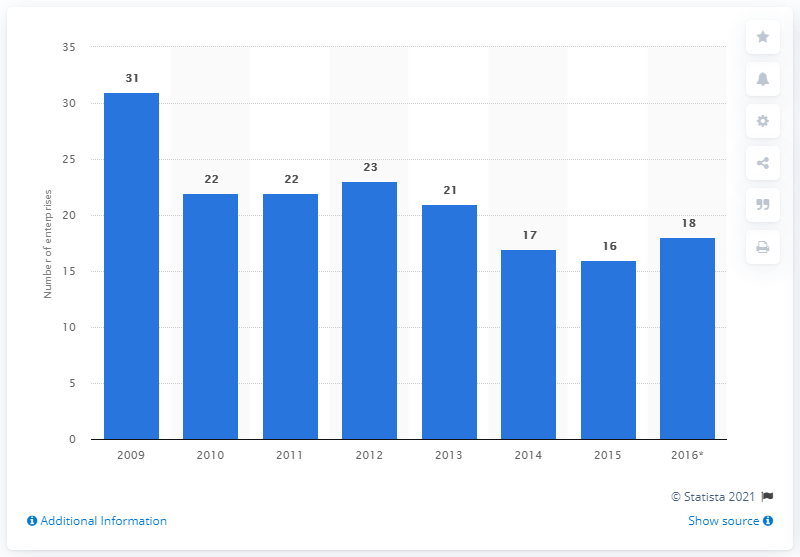List a handful of essential elements in this visual. In 2015, there were 16 enterprises in the Czech Republic that were engaged in the manufacturing of basic pharmaceutical products. 